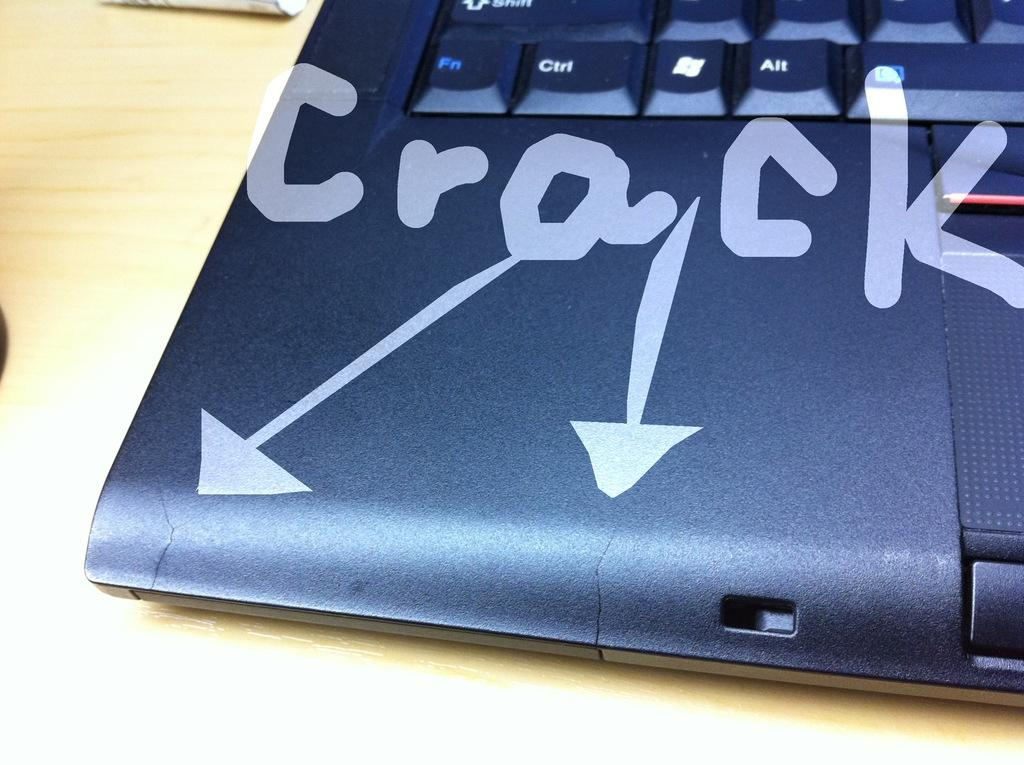What electronic device is partially visible in the image? There is a part of a laptop in the image. What can be seen on the laptop's surface? There is writing on the laptop. What type of surface is the laptop resting on? The laptop is on a wooden surface. How many children are celebrating a birthday in the image? There are no children or birthday celebration present in the image; it features a part of a laptop on a wooden surface. 